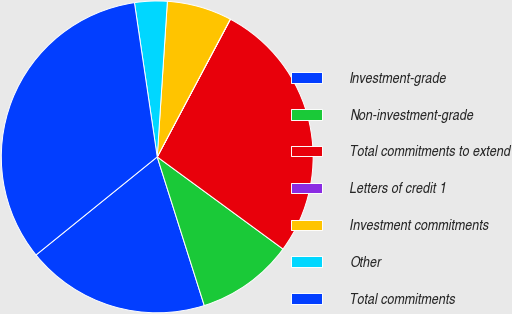Convert chart to OTSL. <chart><loc_0><loc_0><loc_500><loc_500><pie_chart><fcel>Investment-grade<fcel>Non-investment-grade<fcel>Total commitments to extend<fcel>Letters of credit 1<fcel>Investment commitments<fcel>Other<fcel>Total commitments<nl><fcel>19.05%<fcel>10.06%<fcel>27.28%<fcel>0.02%<fcel>6.72%<fcel>3.37%<fcel>33.49%<nl></chart> 